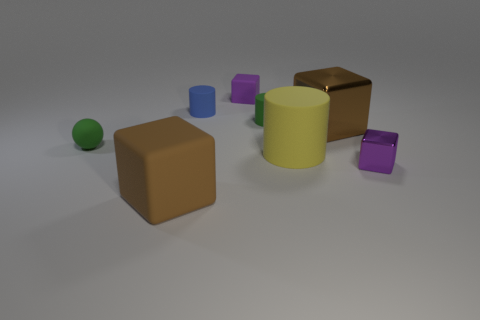Do the tiny metallic thing and the small matte block have the same color?
Your answer should be compact. Yes. There is another blue cylinder that is the same material as the large cylinder; what is its size?
Your answer should be very brief. Small. There is another cube that is the same color as the tiny rubber cube; what is its size?
Keep it short and to the point. Small. How many other cylinders have the same material as the green cylinder?
Ensure brevity in your answer.  2. How many purple rubber cubes are the same size as the blue thing?
Ensure brevity in your answer.  1. What is the small purple block behind the matte cylinder in front of the large brown object that is behind the purple metallic block made of?
Offer a terse response. Rubber. What number of things are large yellow rubber things or tiny purple rubber blocks?
Offer a terse response. 2. There is a purple shiny object; what shape is it?
Offer a very short reply. Cube. The small green thing to the left of the small rubber cylinder that is in front of the blue matte cylinder is what shape?
Your answer should be very brief. Sphere. Are the small purple cube in front of the large brown metal object and the large yellow thing made of the same material?
Your answer should be very brief. No. 